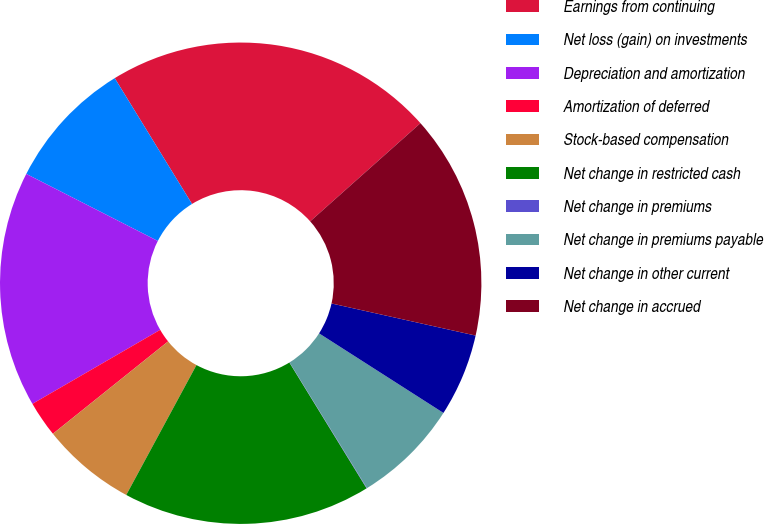Convert chart. <chart><loc_0><loc_0><loc_500><loc_500><pie_chart><fcel>Earnings from continuing<fcel>Net loss (gain) on investments<fcel>Depreciation and amortization<fcel>Amortization of deferred<fcel>Stock-based compensation<fcel>Net change in restricted cash<fcel>Net change in premiums<fcel>Net change in premiums payable<fcel>Net change in other current<fcel>Net change in accrued<nl><fcel>22.19%<fcel>8.73%<fcel>15.86%<fcel>2.4%<fcel>6.36%<fcel>16.65%<fcel>0.03%<fcel>7.15%<fcel>5.57%<fcel>15.07%<nl></chart> 